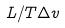Convert formula to latex. <formula><loc_0><loc_0><loc_500><loc_500>L / T \Delta v</formula> 